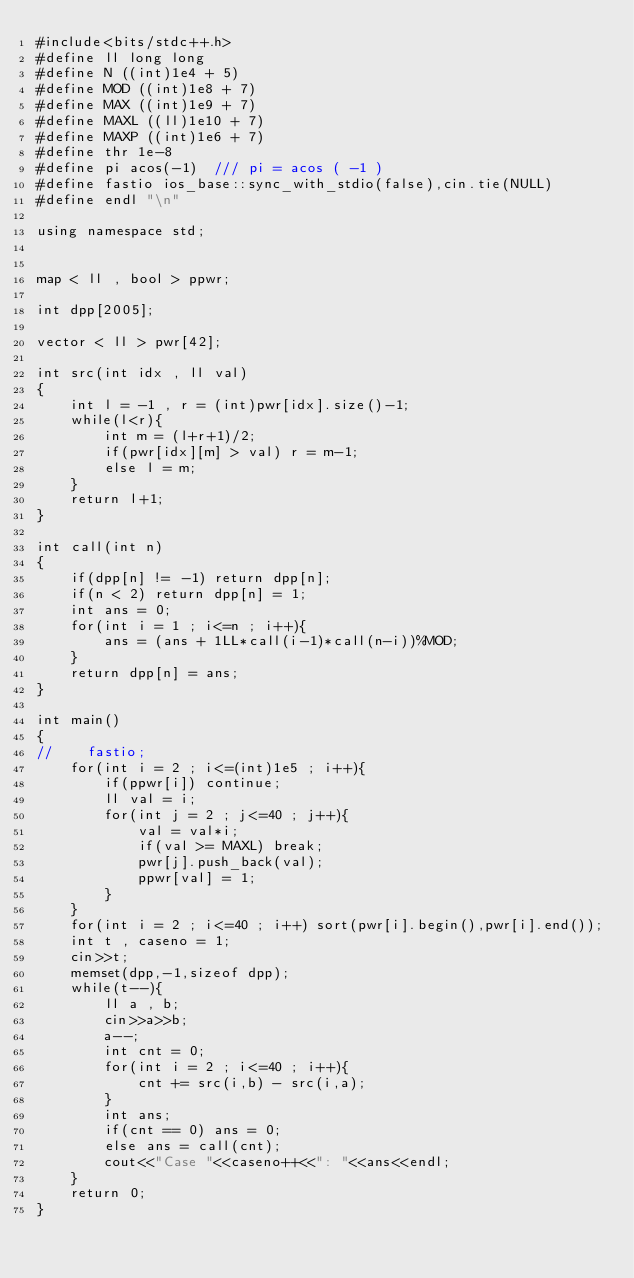<code> <loc_0><loc_0><loc_500><loc_500><_C++_>#include<bits/stdc++.h>
#define ll long long
#define N ((int)1e4 + 5)
#define MOD ((int)1e8 + 7)
#define MAX ((int)1e9 + 7)
#define MAXL ((ll)1e10 + 7)
#define MAXP ((int)1e6 + 7)
#define thr 1e-8
#define pi acos(-1)  /// pi = acos ( -1 )
#define fastio ios_base::sync_with_stdio(false),cin.tie(NULL)
#define endl "\n"

using namespace std;


map < ll , bool > ppwr;

int dpp[2005];

vector < ll > pwr[42];

int src(int idx , ll val)
{
    int l = -1 , r = (int)pwr[idx].size()-1;
    while(l<r){
        int m = (l+r+1)/2;
        if(pwr[idx][m] > val) r = m-1;
        else l = m;
    }
    return l+1;
}

int call(int n)
{
    if(dpp[n] != -1) return dpp[n];
    if(n < 2) return dpp[n] = 1;
    int ans = 0;
    for(int i = 1 ; i<=n ; i++){
        ans = (ans + 1LL*call(i-1)*call(n-i))%MOD;
    }
    return dpp[n] = ans;
}

int main()
{
//    fastio;
    for(int i = 2 ; i<=(int)1e5 ; i++){
        if(ppwr[i]) continue;
        ll val = i;
        for(int j = 2 ; j<=40 ; j++){
            val = val*i;
            if(val >= MAXL) break;
            pwr[j].push_back(val);
            ppwr[val] = 1;
        }
    }
    for(int i = 2 ; i<=40 ; i++) sort(pwr[i].begin(),pwr[i].end());
    int t , caseno = 1;
    cin>>t;
    memset(dpp,-1,sizeof dpp);
    while(t--){
        ll a , b;
        cin>>a>>b;
        a--;
        int cnt = 0;
        for(int i = 2 ; i<=40 ; i++){
            cnt += src(i,b) - src(i,a);
        }
        int ans;
        if(cnt == 0) ans = 0;
        else ans = call(cnt);
        cout<<"Case "<<caseno++<<": "<<ans<<endl;
    }
    return 0;
}
</code> 